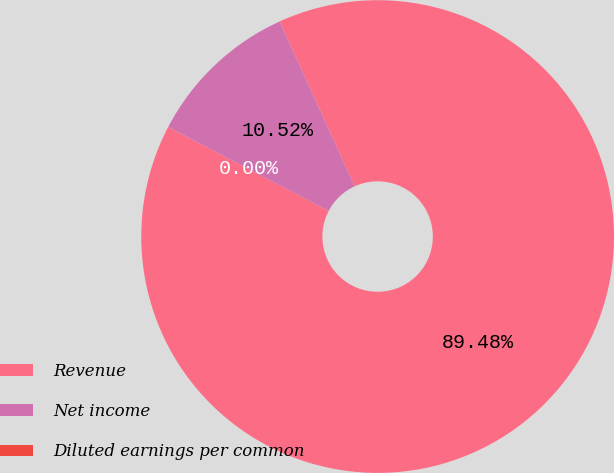<chart> <loc_0><loc_0><loc_500><loc_500><pie_chart><fcel>Revenue<fcel>Net income<fcel>Diluted earnings per common<nl><fcel>89.48%<fcel>10.52%<fcel>0.0%<nl></chart> 